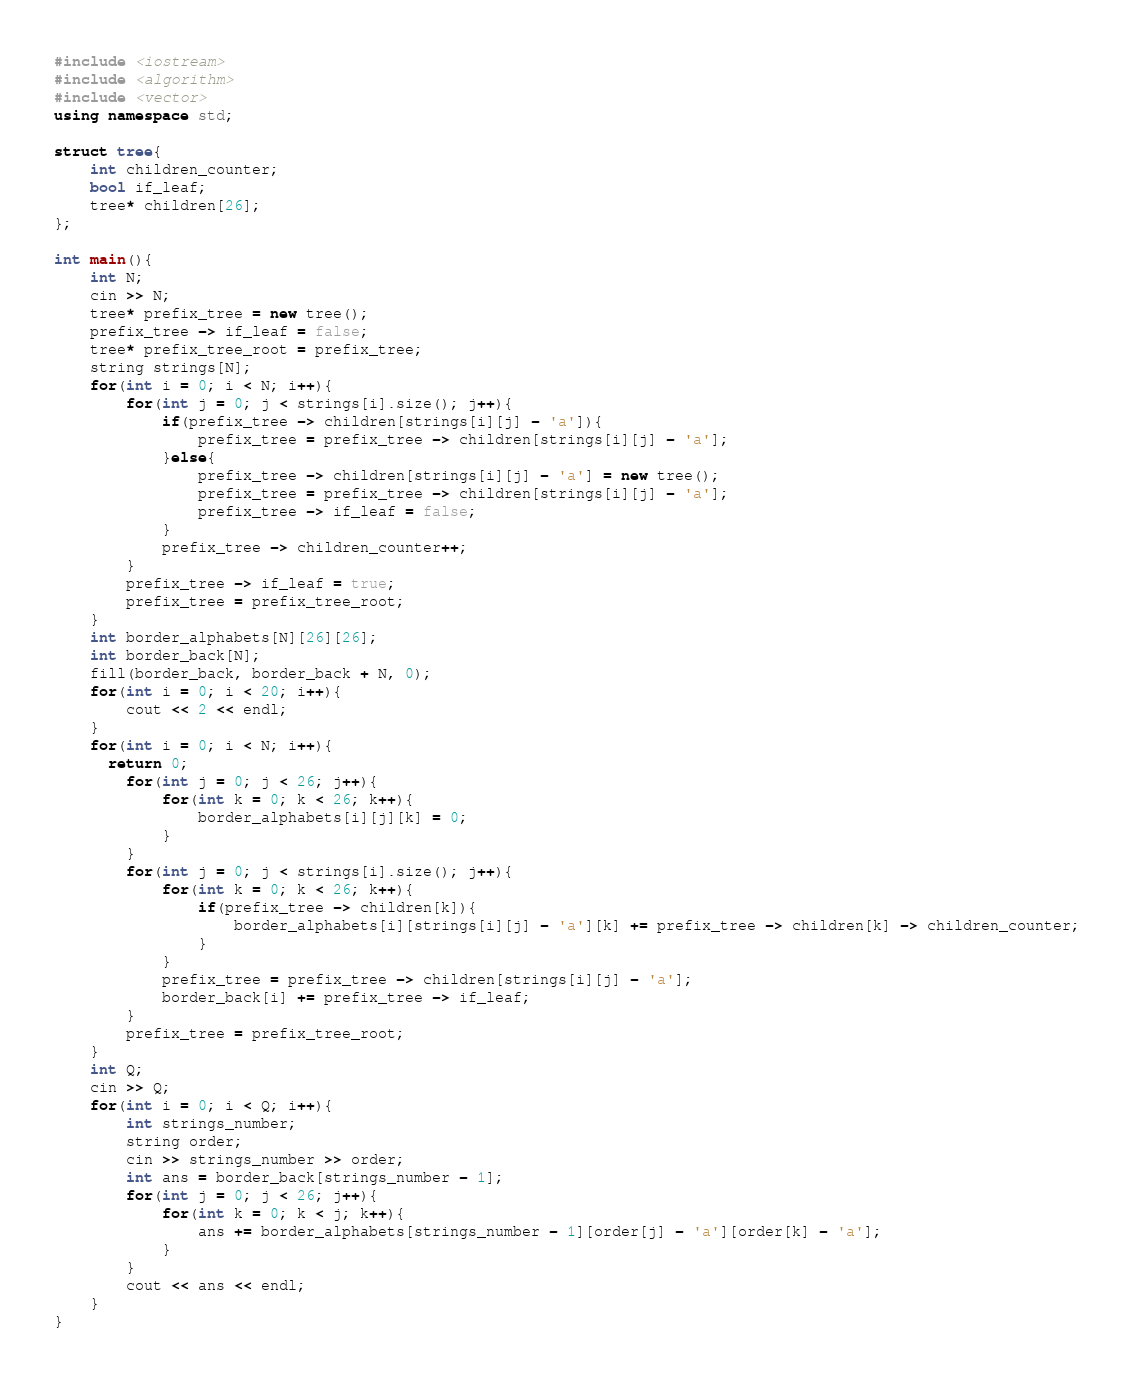<code> <loc_0><loc_0><loc_500><loc_500><_C++_>#include <iostream>
#include <algorithm>
#include <vector>
using namespace std;

struct tree{
    int children_counter;
    bool if_leaf;
    tree* children[26];
};

int main(){
    int N;
    cin >> N;
    tree* prefix_tree = new tree();
    prefix_tree -> if_leaf = false;
    tree* prefix_tree_root = prefix_tree;
    string strings[N];
    for(int i = 0; i < N; i++){
        for(int j = 0; j < strings[i].size(); j++){
            if(prefix_tree -> children[strings[i][j] - 'a']){
                prefix_tree = prefix_tree -> children[strings[i][j] - 'a'];
            }else{
                prefix_tree -> children[strings[i][j] - 'a'] = new tree();
                prefix_tree = prefix_tree -> children[strings[i][j] - 'a'];
                prefix_tree -> if_leaf = false;
            }
            prefix_tree -> children_counter++;
        }
        prefix_tree -> if_leaf = true;
        prefix_tree = prefix_tree_root;
    }
    int border_alphabets[N][26][26];
    int border_back[N];
    fill(border_back, border_back + N, 0);
    for(int i = 0; i < 20; i++){
        cout << 2 << endl;
    }
    for(int i = 0; i < N; i++){
      return 0;
        for(int j = 0; j < 26; j++){
            for(int k = 0; k < 26; k++){
                border_alphabets[i][j][k] = 0;
            }
        }
        for(int j = 0; j < strings[i].size(); j++){
            for(int k = 0; k < 26; k++){
                if(prefix_tree -> children[k]){
                    border_alphabets[i][strings[i][j] - 'a'][k] += prefix_tree -> children[k] -> children_counter;
                }
            }
            prefix_tree = prefix_tree -> children[strings[i][j] - 'a'];
            border_back[i] += prefix_tree -> if_leaf;
        }
        prefix_tree = prefix_tree_root;
    }
    int Q;
    cin >> Q;
    for(int i = 0; i < Q; i++){
        int strings_number;
        string order;
        cin >> strings_number >> order;
        int ans = border_back[strings_number - 1];
        for(int j = 0; j < 26; j++){
            for(int k = 0; k < j; k++){
                ans += border_alphabets[strings_number - 1][order[j] - 'a'][order[k] - 'a'];
            }
        }
        cout << ans << endl;
    }
}
</code> 